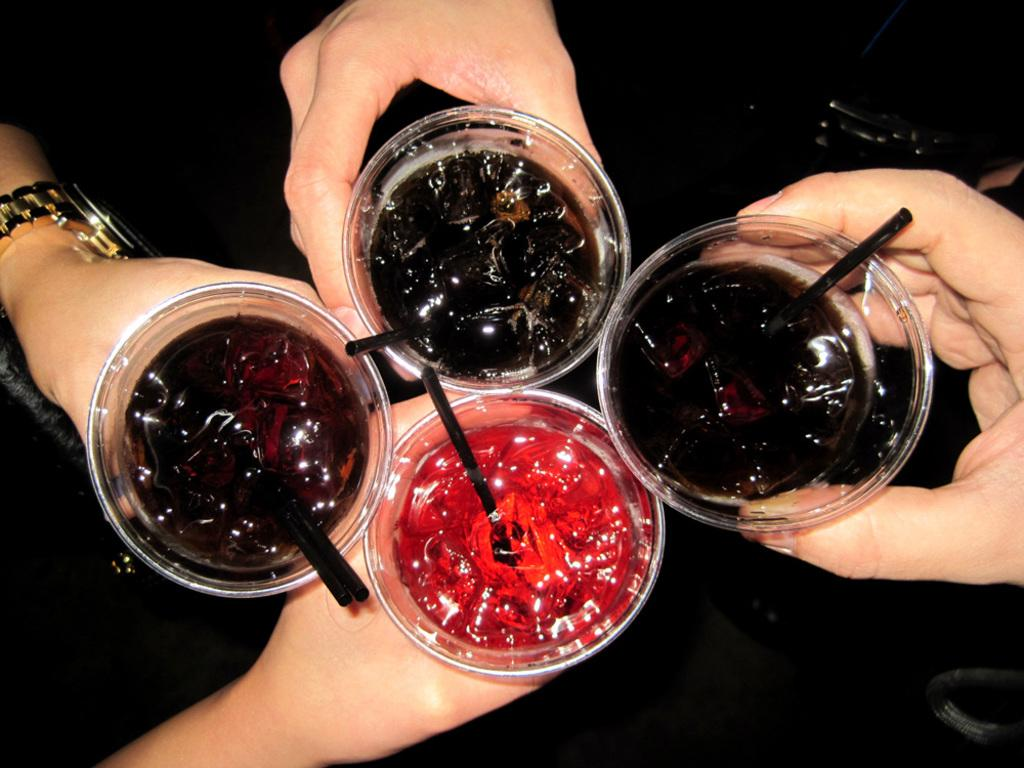What types of drinks can be seen in the image? There are different colors of drinks in the image. How are the drinks being held in the image? The drinks are held by persons' hands. What type of dolls can be seen in the image? There are no dolls present in the image, so it is not possible to describe any dolls. 